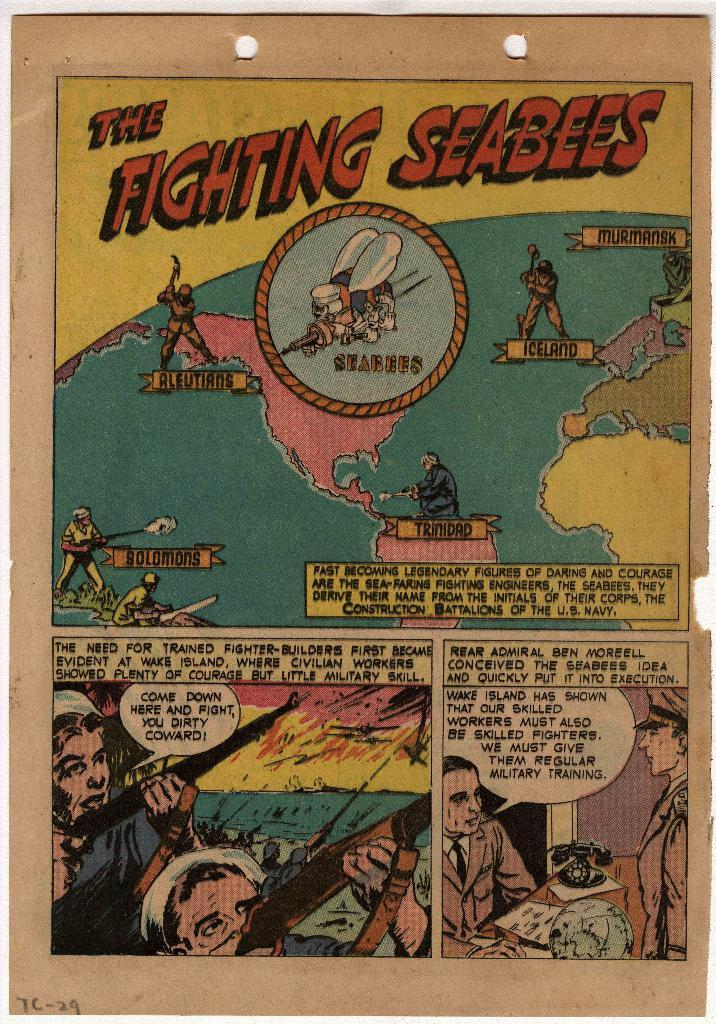<image>
Summarize the visual content of the image. A page from a The Fighting Seabees comic book. 